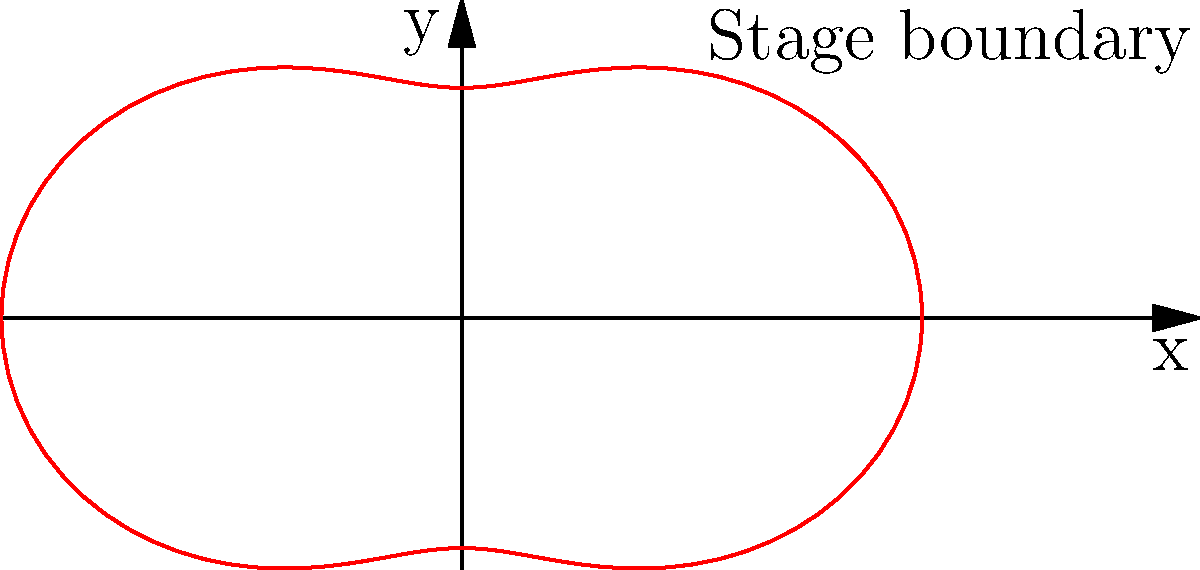At a comedy club where James Adomian frequently performs, the stage has an unusual shape represented by the polar equation $r = 3 + \cos(2\theta)$. If the club owner wants to calculate the area of the stage to determine how many comedians can safely perform while maintaining social distancing, what is the area of the stage in square units? To find the area of the stage, we need to use the formula for area in polar coordinates:

$$A = \frac{1}{2} \int_{0}^{2\pi} r^2(\theta) d\theta$$

Where $r(\theta) = 3 + \cos(2\theta)$

Step 1: Square the radius function
$$r^2(\theta) = (3 + \cos(2\theta))^2 = 9 + 6\cos(2\theta) + \cos^2(2\theta)$$

Step 2: Integrate $r^2(\theta)$ from 0 to $2\pi$
$$A = \frac{1}{2} \int_{0}^{2\pi} (9 + 6\cos(2\theta) + \cos^2(2\theta)) d\theta$$

Step 3: Integrate each term
- $\int_{0}^{2\pi} 9 d\theta = 9 \cdot 2\pi = 18\pi$
- $\int_{0}^{2\pi} 6\cos(2\theta) d\theta = 0$ (integral of cosine over full period)
- $\int_{0}^{2\pi} \cos^2(2\theta) d\theta = \pi$ (using the half-angle formula)

Step 4: Sum up the results and multiply by $\frac{1}{2}$
$$A = \frac{1}{2} (18\pi + 0 + \pi) = \frac{19\pi}{2}$$

Therefore, the area of the stage is $\frac{19\pi}{2}$ square units.
Answer: $\frac{19\pi}{2}$ square units 